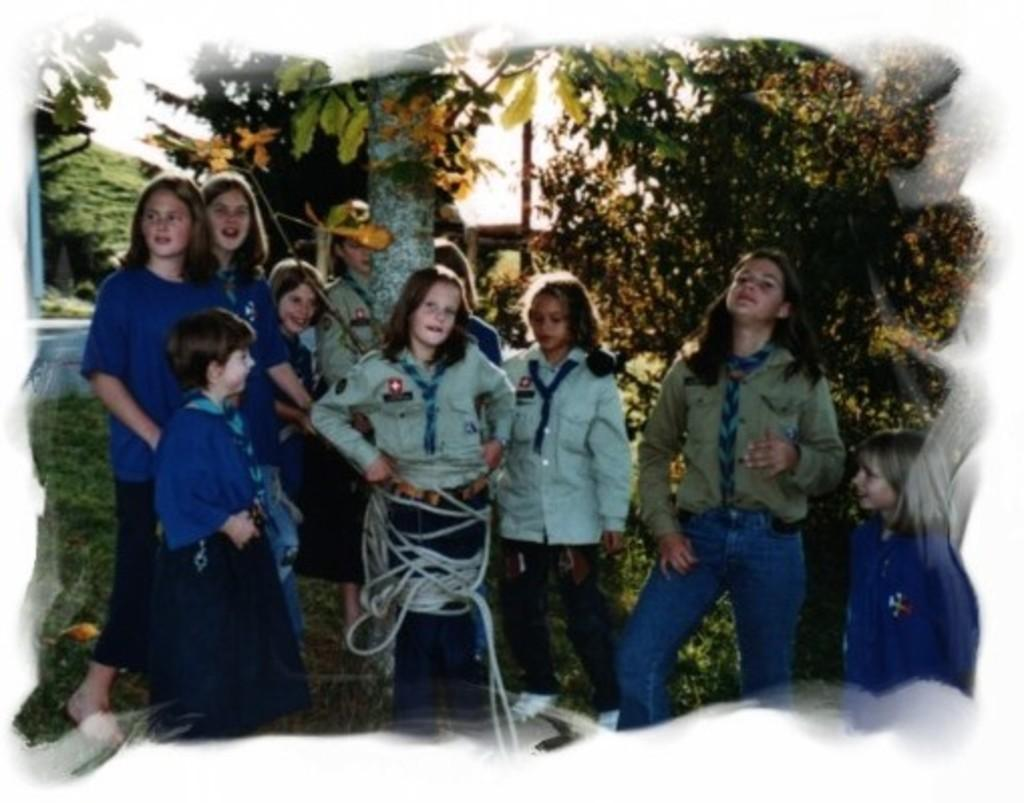How many people are in the image? There are people in the image, but the exact number is not specified. What type of terrain is visible in the image? There is grass in the image, which suggests a natural, outdoor setting. What object can be seen in the image that might be used for tying or securing? There is a rope in the image, which could be used for tying or securing. What type of vegetation is present in the image? There are trees in the image, which indicates the presence of plant life. What is visible in the background of the image? The sky is visible in the background of the image, providing context for the setting. What type of wax can be seen dripping from the trees in the image? There is no wax present in the image, and therefore no such activity can be observed. 